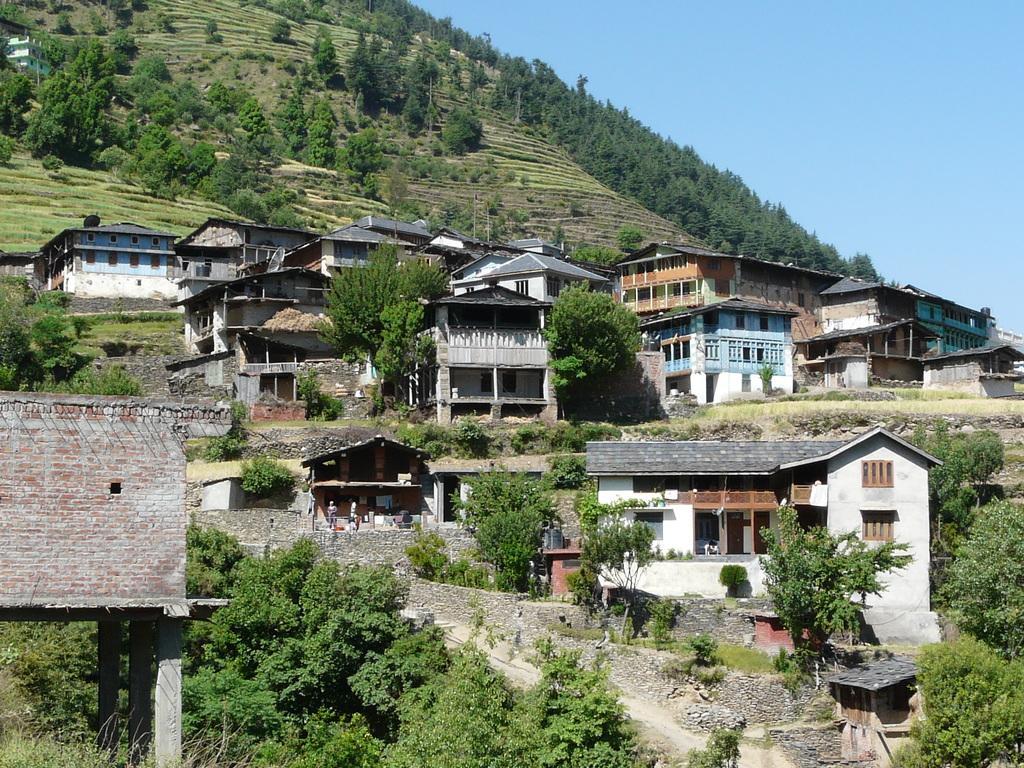Describe this image in one or two sentences. In this image we can see houses, trees, poles and building. In the background there is sky. 